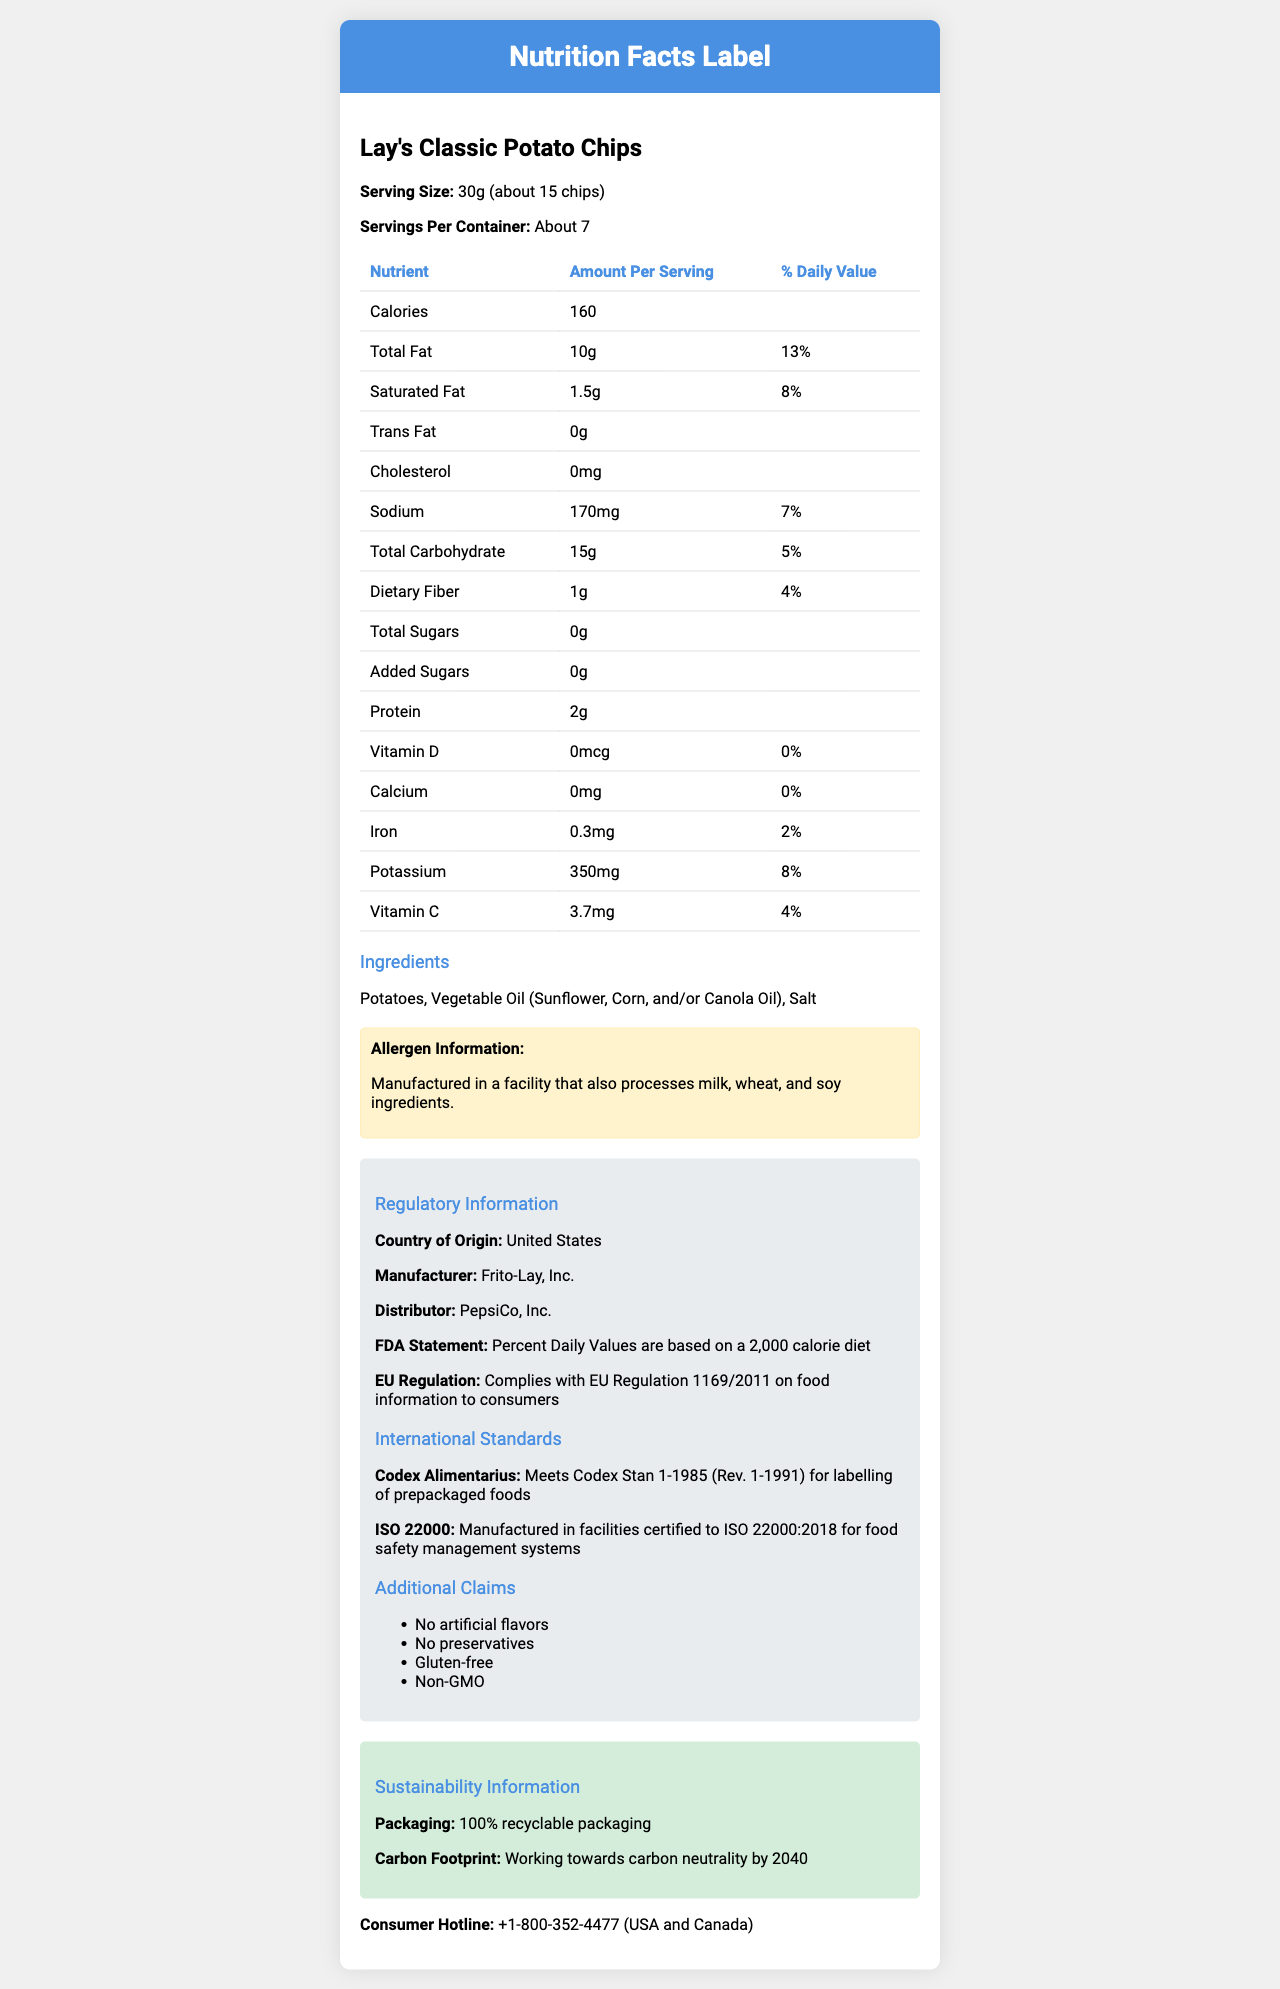when was the product manufactured? The document lists the product name, nutrition facts, ingredients, allergens, regulatory, and sustainability information, but it does not provide a manufacturing date.
Answer: Not enough information what is the serving size for Lay's Classic Potato Chips? The document explicitly mentions that the serving size for Lay's Classic Potato Chips is 30g, which is approximately 15 chips.
Answer: 30g (about 15 chips) how many calories per serving are in Lay's Classic Potato Chips? The document states that there are 160 calories per serving.
Answer: 160 which allergens are processed in the facility that manufactures this product? A. Peanut and Tree nut B. Milk, Wheat, and Soy C. Fish and Shellfish D. Egg and Gluten The document specifies that the product is manufactured in a facility that also processes milk, wheat, and soy ingredients.
Answer: B does Lay's Classic Potato Chips contain any added sugars? The nutrition facts indicate that the total amount of added sugars is 0g.
Answer: No what is the daily value percentage for total fat per serving? The document states that the total fat content per serving is 10g, which is 13% of the daily value.
Answer: 13% which nutrient has the highest daily value percentage per serving? A. Calcium B. Iron C. Potassium D. Dietary Fiber E. Vitamin C Potassium has the highest daily value percentage per serving at 8%.
Answer: C is this product gluten-free? Under the additional claims section, the product is mentioned as gluten-free.
Answer: Yes what is the carbon footprint goal for Lay's Classic Potato Chips? The sustainability information section indicates that the product is working towards carbon neutrality by 2040.
Answer: Working towards carbon neutrality by 2040 summarize the main details provided in the document about Lay's Classic Potato Chips. The document gives a complete overview of the nutritional content, ingredient sources, allergen information, regulatory compliance, additional claims, sustainability efforts, and customer service contact details for Lay's Classic Potato Chips. This information helps consumers understand the product’s health implications, safety, and environmental impact.
Answer: The document provides comprehensive nutrition facts for Lay's Classic Potato Chips, including serving size, calories, and percentages of daily value for various nutrients. It lists ingredients and allergens, regulatory information, additional claims like "no artificial flavors" and "gluten-free," international standards compliance, and sustainability efforts involving recyclable packaging and carbon neutrality by 2040. It also provides a consumer hotline. what type of oil is used in Lay's Classic Potato Chips? The ingredients list in the document mentions that the product contains Vegetable Oil which could be Sunflower, Corn, or Canola Oil.
Answer: Vegetable Oil (Sunflower, Corn, and/or Canola Oil) what amount of sodium is present per serving, and what is its daily value percentage? The nutrition facts table shows that each serving contains 170mg of sodium, which represents 7% of the daily value.
Answer: 170mg, 7% is this product free from preservatives? The additional claims section states that the product contains no preservatives.
Answer: Yes which international standards does Lay's Classic Potato Chips comply with? According to the international standards section, the product meets Codex Stan 1-1985 for labeling and is manufactured in a facility certified to ISO 22000:2018 for food safety management systems.
Answer: Codex Stan 1-1985 (Rev. 1-1991) for labelling and ISO 22000:2018 for food safety management systems who manufactures and distributes Lay's Classic Potato Chips? The regulatory information section indicates that Frito-Lay, Inc. manufactures the product, and PepsiCo, Inc. distributes it.
Answer: Frito-Lay, Inc. (manufacturer) and PepsiCo, Inc. (distributor) what is the amount of protein per serving in Lay's Classic Potato Chips? The nutrition facts indicate that there are 2g of protein per serving.
Answer: 2g what is the vitamin C content per serving and its daily value percentage? The nutrition facts reveal that each serving contains 3.7mg of vitamin C, which is 4% of the daily value.
Answer: 3.7mg, 4% 